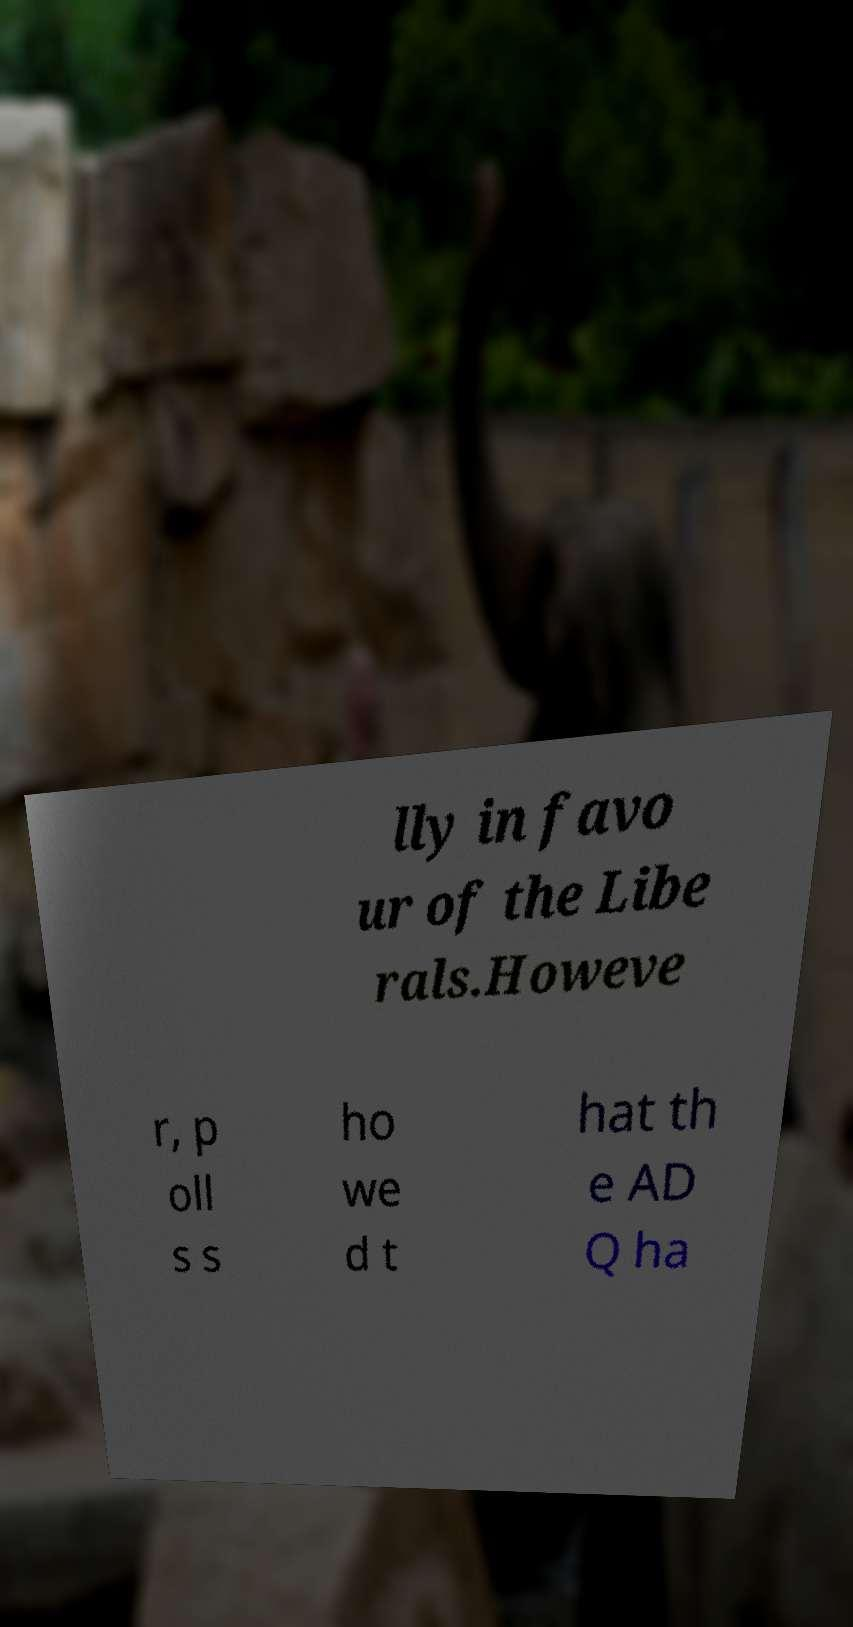For documentation purposes, I need the text within this image transcribed. Could you provide that? lly in favo ur of the Libe rals.Howeve r, p oll s s ho we d t hat th e AD Q ha 